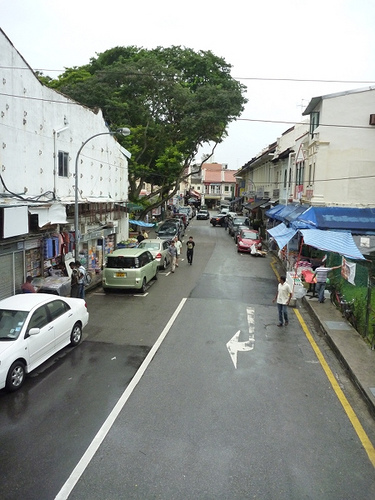<image>
Is the arrow on the road? Yes. Looking at the image, I can see the arrow is positioned on top of the road, with the road providing support. Is there a sky behind the man? Yes. From this viewpoint, the sky is positioned behind the man, with the man partially or fully occluding the sky. Is there a sky behind the building? Yes. From this viewpoint, the sky is positioned behind the building, with the building partially or fully occluding the sky. Is there a man behind the car? No. The man is not behind the car. From this viewpoint, the man appears to be positioned elsewhere in the scene. Where is the car in relation to the man? Is it behind the man? No. The car is not behind the man. From this viewpoint, the car appears to be positioned elsewhere in the scene. 